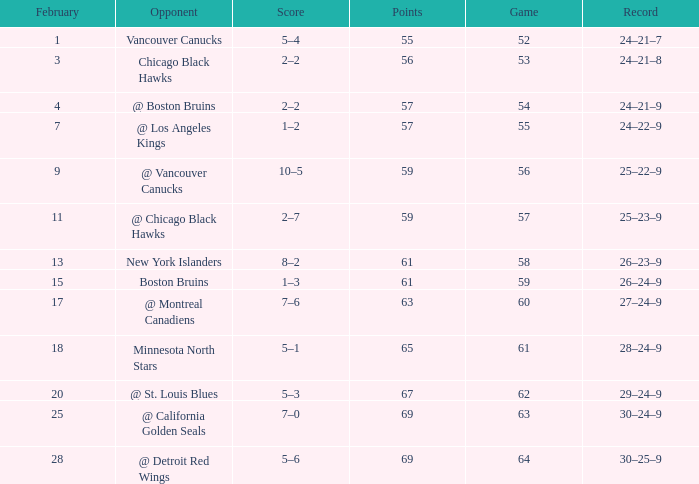How many february games had a record of 29–24–9? 20.0. 